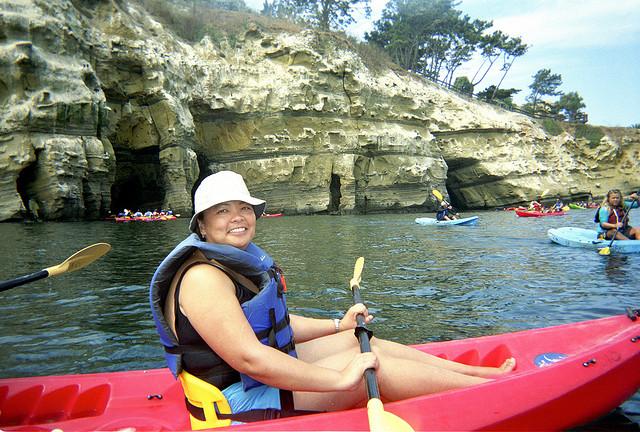Is this a double kayak?
Give a very brief answer. Yes. How many boats are there?
Give a very brief answer. 6. What color is the boat?
Write a very short answer. Red. 